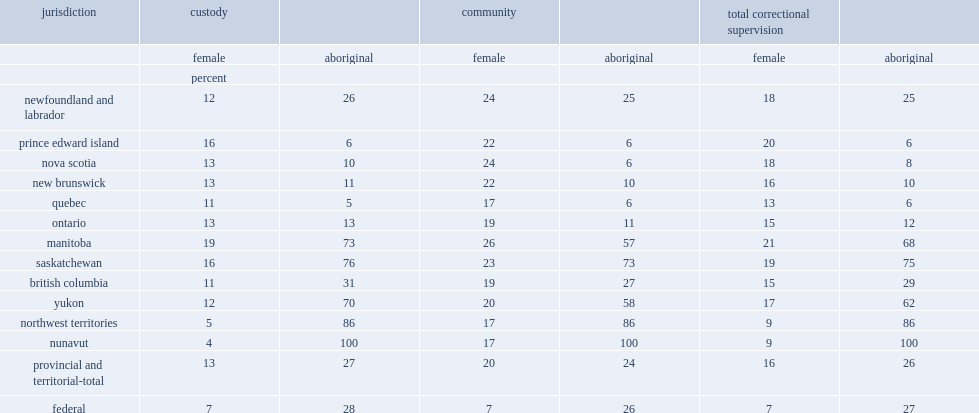In 2015/2016, what was the percent of adults admitted to provincial and territorial correctional services were women? 16.0. What the proportion of community admissions did women account for? 20.0. What the proportion of custody admissions did women account for? 13.0. What was the percent of women represented of admissions to community supervision? 7.0. What was the percent of aboriginal adults were provincial and territorial custodial admissions? 27.0. What was the percent of aboriginal adults were provincial and territorial community admissions? 24.0. What the percent of admissions to custody did aboriginal adults in federal correctional services account for in 2015/2016? 28.0. What the percent of admissions to community supervision did aboriginal adults in federal correctional services account for in 2015/2016? 26.0. 